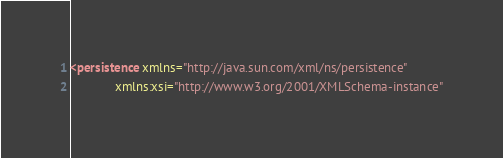<code> <loc_0><loc_0><loc_500><loc_500><_XML_><persistence xmlns="http://java.sun.com/xml/ns/persistence"
			 xmlns:xsi="http://www.w3.org/2001/XMLSchema-instance"</code> 